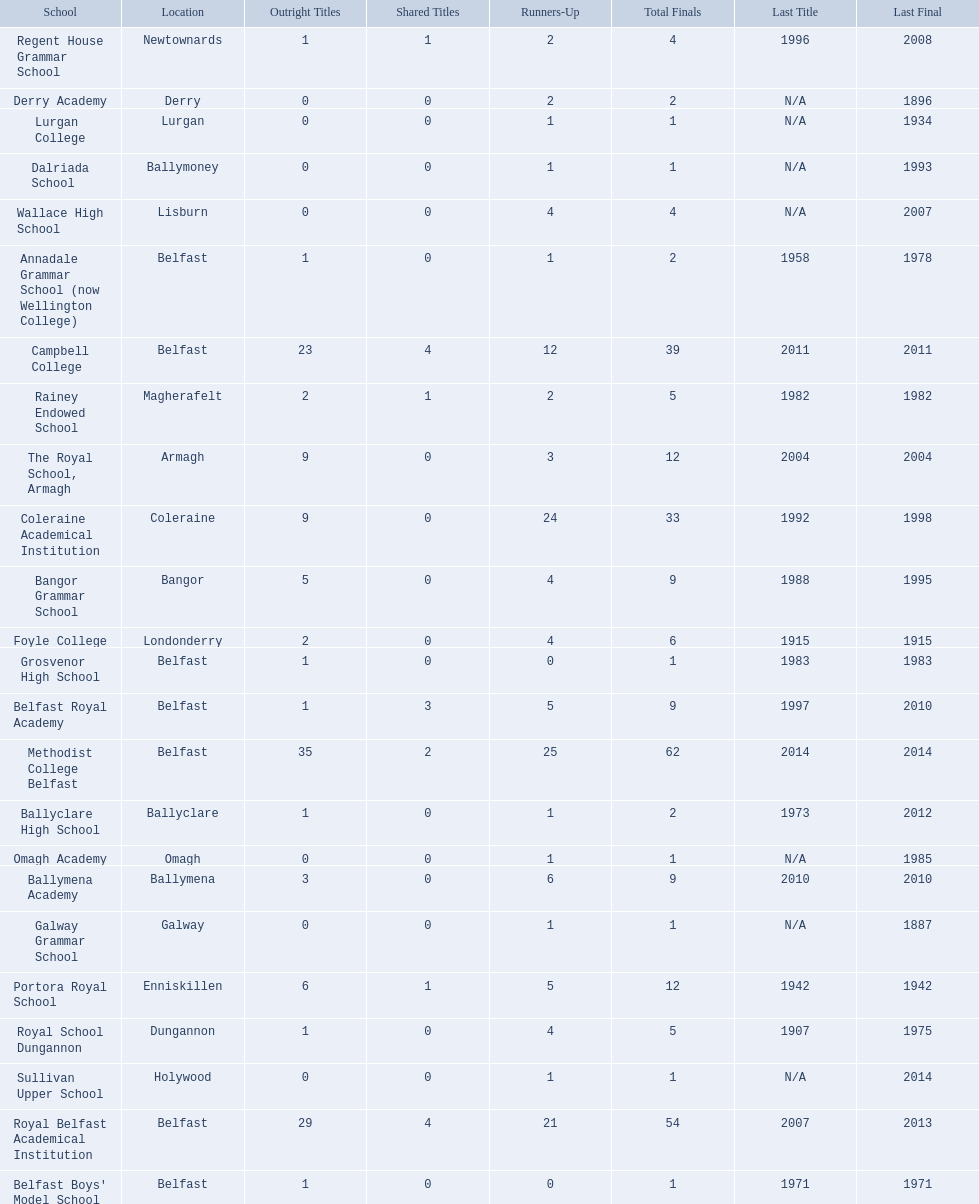How many schools are there? Methodist College Belfast, Royal Belfast Academical Institution, Campbell College, Coleraine Academical Institution, The Royal School, Armagh, Portora Royal School, Bangor Grammar School, Ballymena Academy, Rainey Endowed School, Foyle College, Belfast Royal Academy, Regent House Grammar School, Royal School Dungannon, Annadale Grammar School (now Wellington College), Ballyclare High School, Belfast Boys' Model School, Grosvenor High School, Wallace High School, Derry Academy, Dalriada School, Galway Grammar School, Lurgan College, Omagh Academy, Sullivan Upper School. How many outright titles does the coleraine academical institution have? 9. What other school has the same number of outright titles? The Royal School, Armagh. 